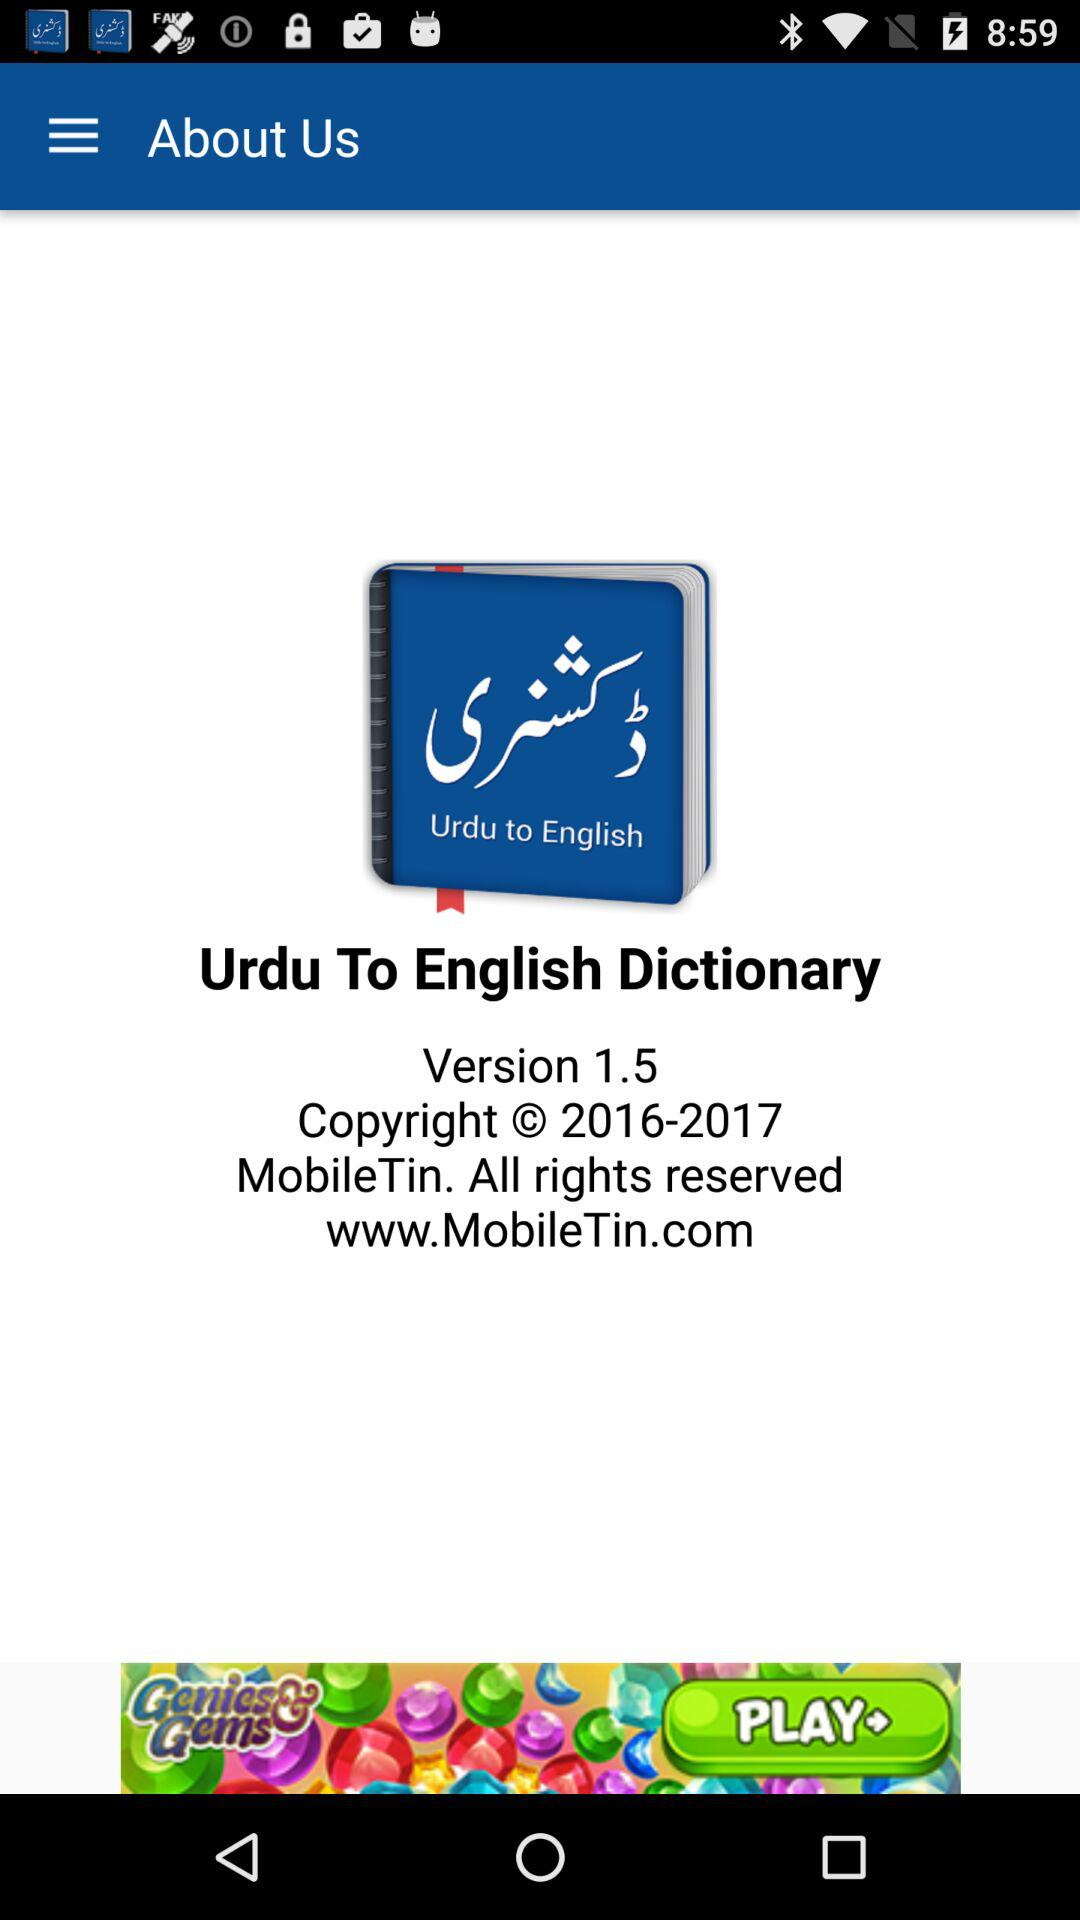Which version of the application is used? The used version is 1.5. 